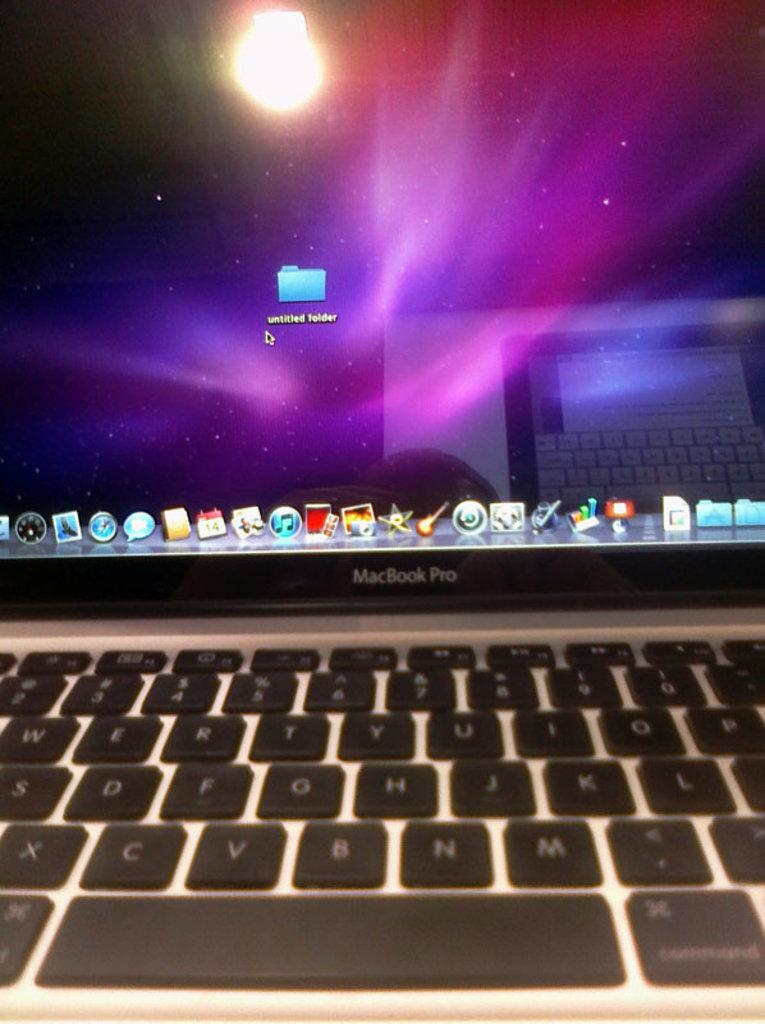<image>
Render a clear and concise summary of the photo. A laptop computer with MacBook Pro on it. 